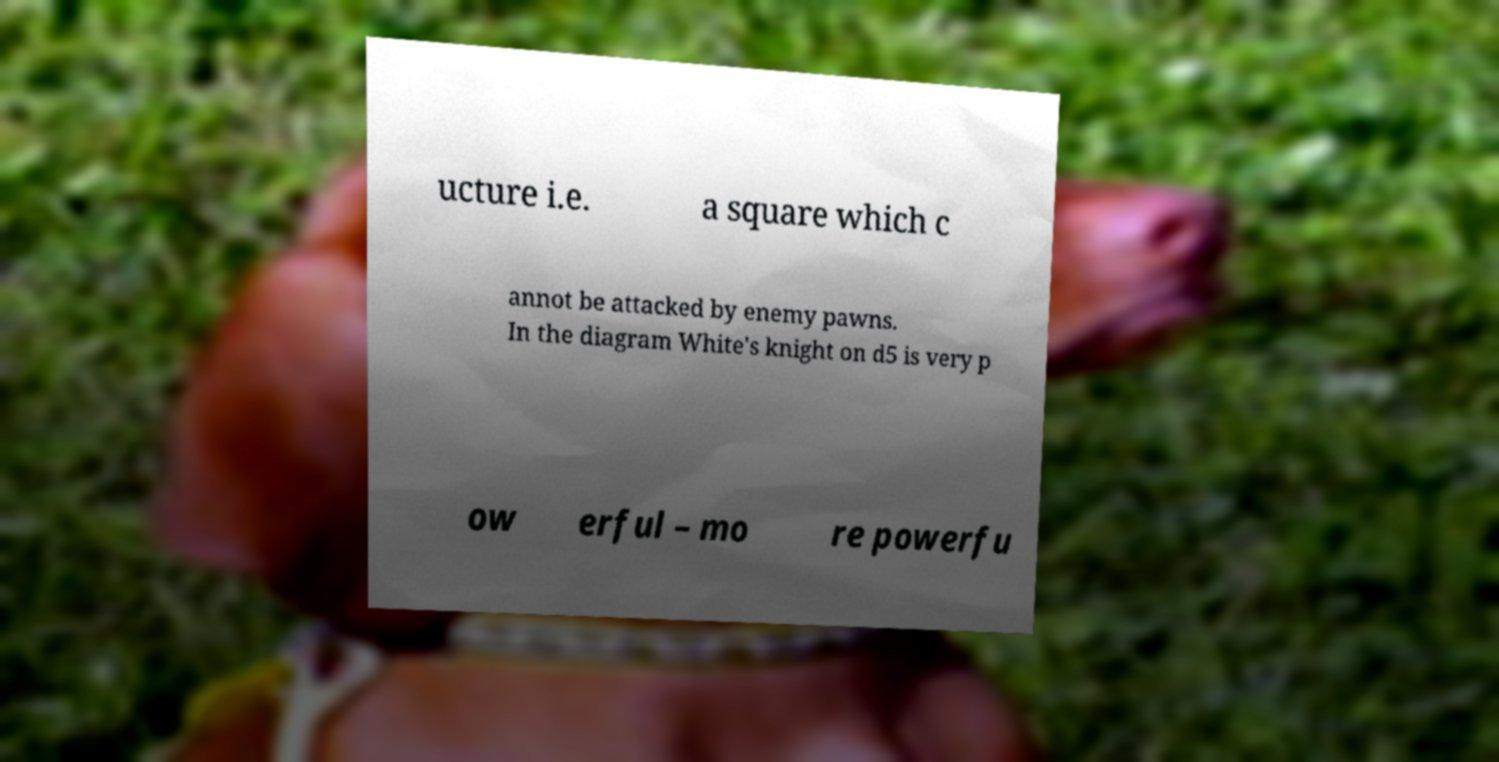Can you read and provide the text displayed in the image?This photo seems to have some interesting text. Can you extract and type it out for me? ucture i.e. a square which c annot be attacked by enemy pawns. In the diagram White's knight on d5 is very p ow erful – mo re powerfu 